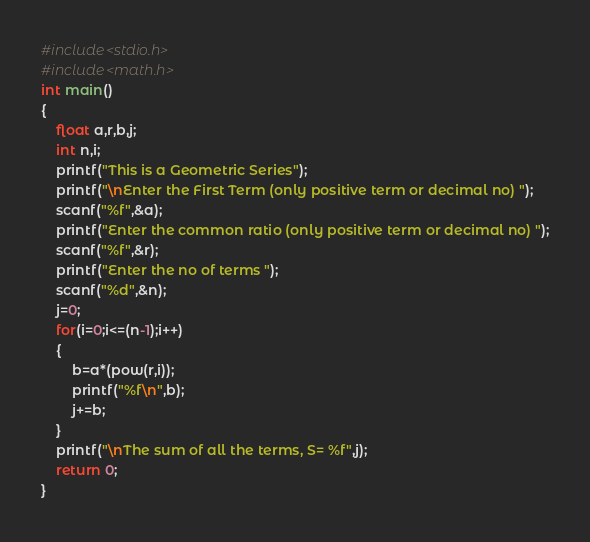<code> <loc_0><loc_0><loc_500><loc_500><_C_>#include<stdio.h>
#include<math.h>
int main()
{
	float a,r,b,j;
	int n,i;
	printf("This is a Geometric Series");
	printf("\nEnter the First Term (only positive term or decimal no) ");
	scanf("%f",&a);
	printf("Enter the common ratio (only positive term or decimal no) ");
	scanf("%f",&r);
	printf("Enter the no of terms ");
	scanf("%d",&n);
	j=0;
	for(i=0;i<=(n-1);i++)
	{
		b=a*(pow(r,i));
		printf("%f\n",b);
		j+=b;
	}
	printf("\nThe sum of all the terms, S= %f",j);
	return 0;
}
</code> 